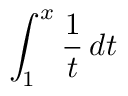<formula> <loc_0><loc_0><loc_500><loc_500>\int _ { 1 } ^ { x } { \frac { 1 } { t } } \, d t</formula> 